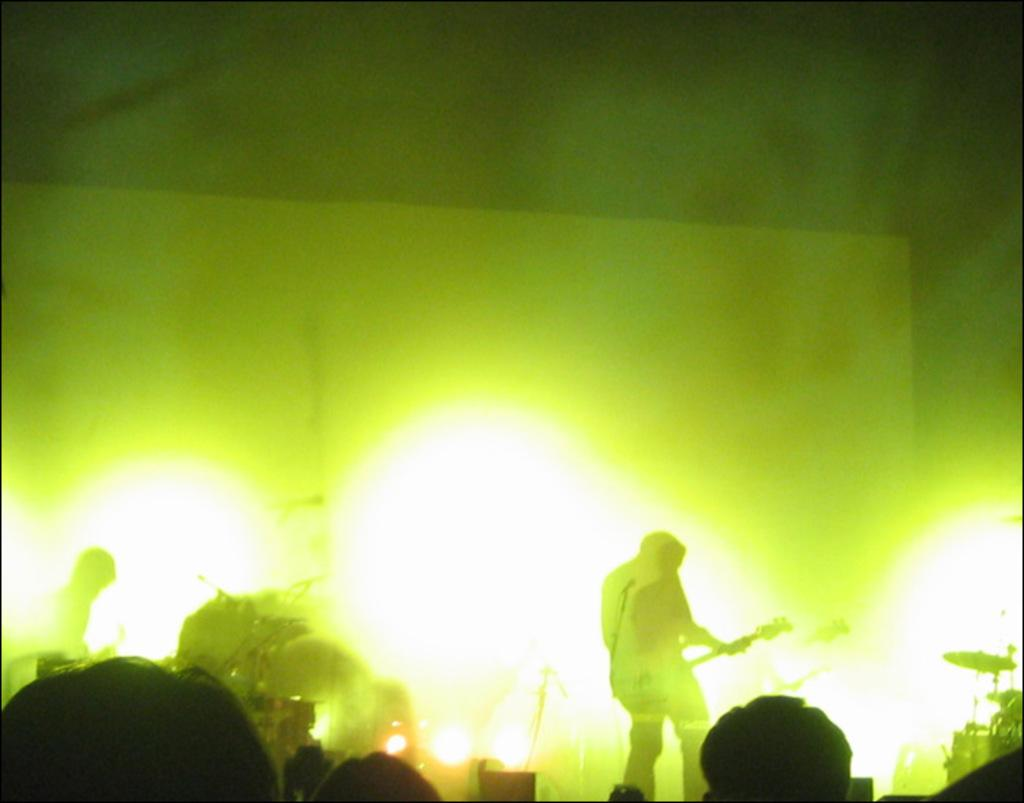What is the man in the image holding? The man is holding a guitar. What type of event might be taking place in the image? There are musical bands in the image, suggesting a concert or performance. Can you describe the person on the left side of the image? There is a person on the left side of the image, but no specific details are provided. What is visible at the bottom of the image? There is a crowd at the bottom of the image. What can be seen in the image that might indicate the presence of a performance? Lights are visible in the image, which could be used to illuminate the stage or performers. What type of coach is visible in the image? There is no coach present in the image. What sign can be seen directing people to the business in the image? There is no sign or business present in the image. 